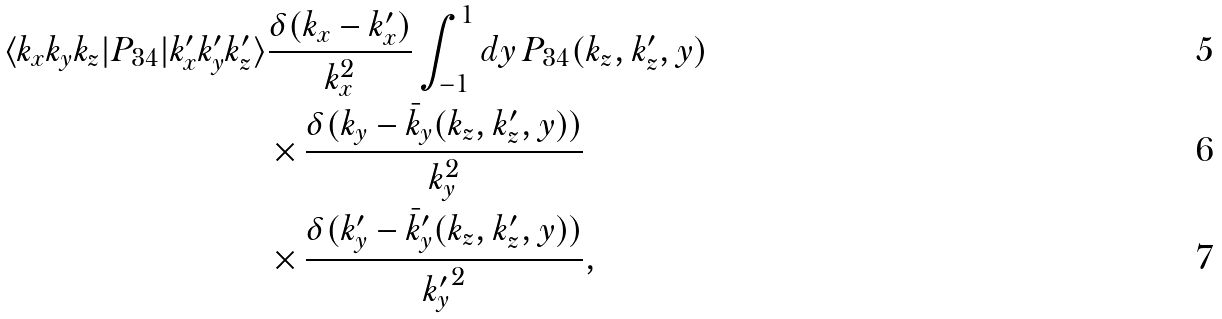Convert formula to latex. <formula><loc_0><loc_0><loc_500><loc_500>\langle k _ { x } k _ { y } k _ { z } | P _ { 3 4 } | k ^ { \prime } _ { x } k ^ { \prime } _ { y } k ^ { \prime } _ { z } \rangle & \frac { \delta ( k _ { x } - k ^ { \prime } _ { x } ) } { k _ { x } ^ { 2 } } \int _ { - 1 } ^ { 1 } d y \, P _ { 3 4 } ( k _ { z } , k ^ { \prime } _ { z } , y ) \\ & \times \frac { \delta ( k _ { y } - \bar { k } _ { y } ( k _ { z } , k ^ { \prime } _ { z } , y ) ) } { k _ { y } ^ { 2 } } \\ & \times \frac { \delta ( k ^ { \prime } _ { y } - \bar { k } ^ { \prime } _ { y } ( k _ { z } , k ^ { \prime } _ { z } , y ) ) } { { k ^ { \prime } _ { y } } ^ { 2 } } ,</formula> 